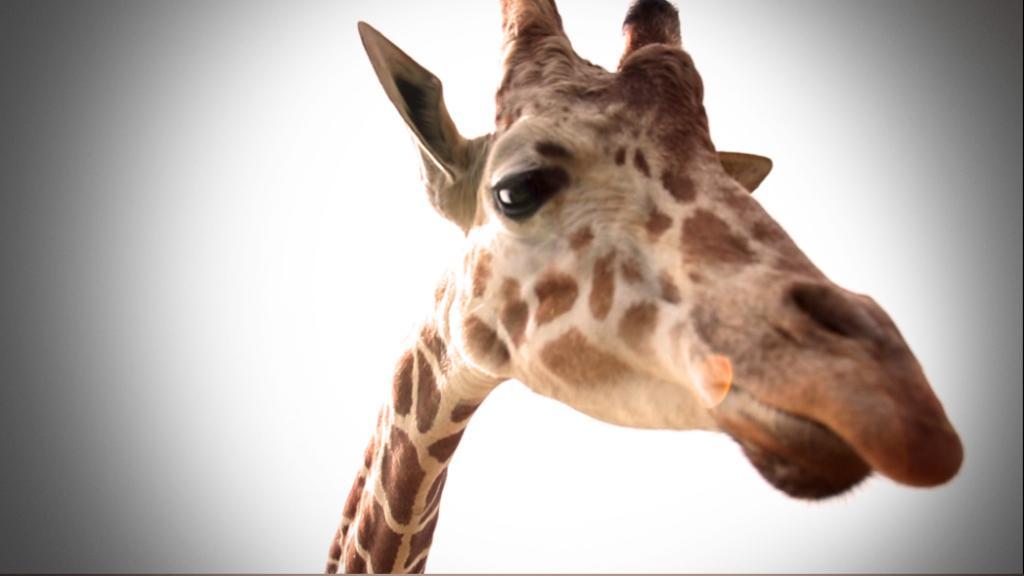Describe this image in one or two sentences. In the center of the image a giraffe neck is there. 